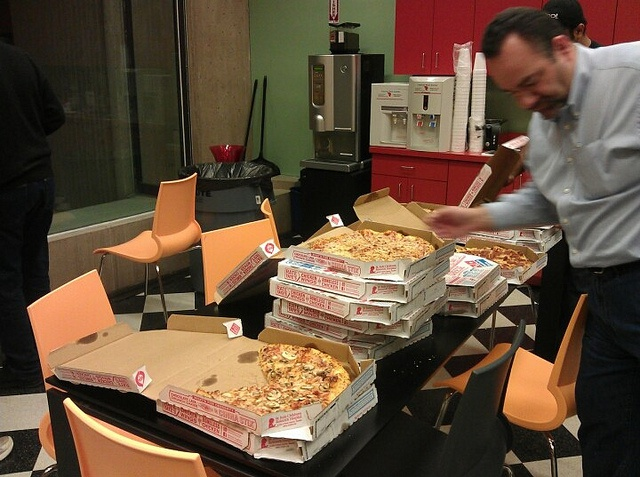Describe the objects in this image and their specific colors. I can see people in black, gray, darkgray, and maroon tones, dining table in black, olive, gray, and maroon tones, people in black, darkgray, and gray tones, chair in black, orange, brown, and maroon tones, and pizza in black, tan, khaki, and brown tones in this image. 